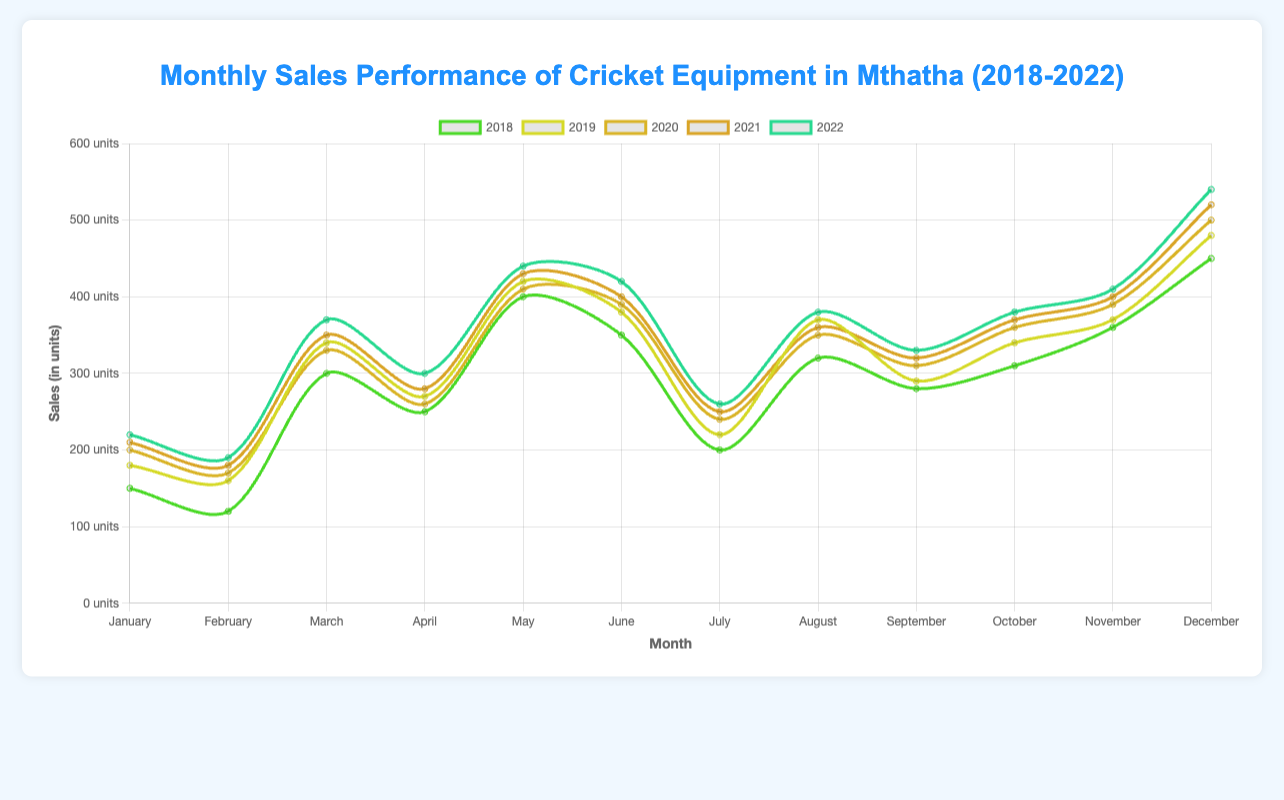What's the month with the highest sales in 2018? Refer to the data points for each month in 2018. December has the highest sales of 450 units.
Answer: December In which year did January experience the highest sales? Compare the sales numbers for January across all five years. The highest sales in January were in 2022 with 220 units.
Answer: 2022 What is the average monthly sales in 2019? Sum the monthly sales for 2019 and divide by 12: (180 + 160 + 340 + 270 + 420 + 380 + 220 + 370 + 290 + 340 + 370 + 480) / 12 = 3810 / 12 = 317.5.
Answer: 317.5 Which year had the most significant increase in sales from February to March? Calculate the difference between March and February for each year and identify the maximum: 2018 (300 - 120 = 180), 2019 (340 - 160 = 180), 2020 (330 - 170 = 160), 2021 (350 - 180 = 170), 2022 (370 - 190 = 180). 2018, 2019, and 2022 all have the highest increase of 180 units.
Answer: 2018, 2019, 2022 In which month do the sales peak each year? Observe the highest sales point for each year: 2018 (December), 2019 (December), 2020 (December), 2021 (December), 2022 (December).
Answer: December By how much did the November sales increase from 2018 to 2022? Subtract the November sales in 2018 from the November sales in 2022: 410 units - 360 units = 50 units.
Answer: 50 units Which year shows the most consistent sales throughout the months, considering the smallest range (difference between highest and lowest sales month)? Calculate the range for each year: 2018 (450-120 = 330), 2019 (480-160 = 320), 2020 (500-170 = 330), 2021 (520-180 = 340), 2022 (540-190 = 350). 2019 shows the smallest range of 320 units.
Answer: 2019 Did the sales in July improve every year from 2018 to 2022? If not, which year saw a decrease? Compare the sales in July year by year: 2018 (200), 2019 (220), 2020 (240), 2021 (250), 2022 (260). Sales improved every year.
Answer: No year saw a decrease What's the total sales for August in the entire dataset? Sum the sales figures for August across all years: 2018 (320) + 2019 (370) + 2020 (350) + 2021 (360) + 2022 (380) = 1780.
Answer: 1780 Is September generally a high-sales or low-sales month compared to others? Compare September sales to other months across all years: They tend to be lower compared to peak months like December and May. The trend suggests lower to moderate sales.
Answer: Low to Moderate 